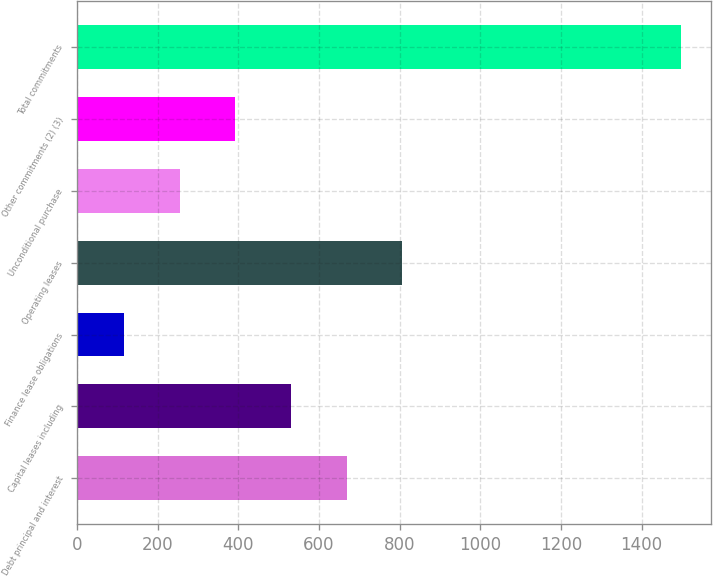Convert chart to OTSL. <chart><loc_0><loc_0><loc_500><loc_500><bar_chart><fcel>Debt principal and interest<fcel>Capital leases including<fcel>Finance lease obligations<fcel>Operating leases<fcel>Unconditional purchase<fcel>Other commitments (2) (3)<fcel>Total commitments<nl><fcel>669<fcel>531<fcel>117<fcel>807<fcel>255<fcel>393<fcel>1497<nl></chart> 